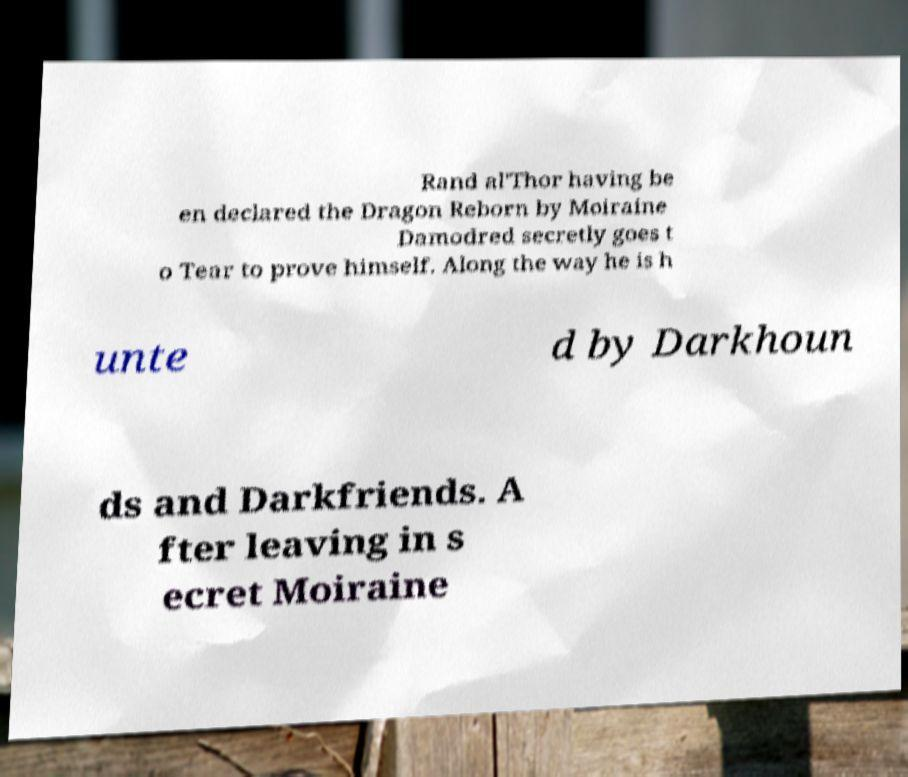Could you assist in decoding the text presented in this image and type it out clearly? Rand al'Thor having be en declared the Dragon Reborn by Moiraine Damodred secretly goes t o Tear to prove himself. Along the way he is h unte d by Darkhoun ds and Darkfriends. A fter leaving in s ecret Moiraine 